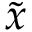<formula> <loc_0><loc_0><loc_500><loc_500>\tilde { x }</formula> 